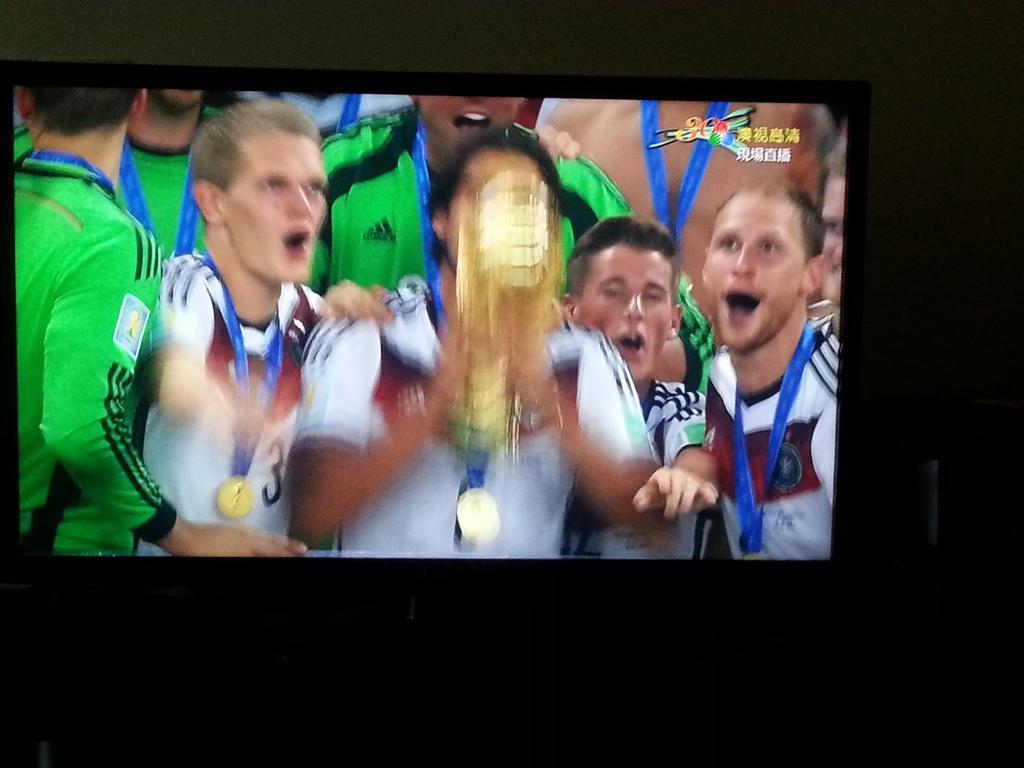Please provide a concise description of this image. In this picture we can see the screen. On the screen we can see some people, trophy and text. In the background of the image we can see the wall. 